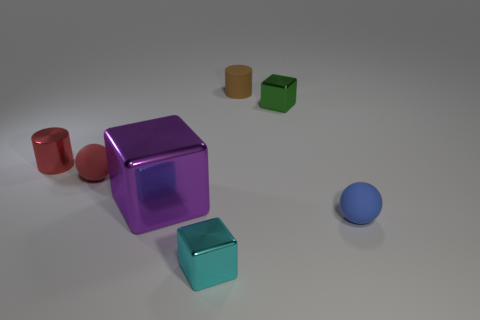Is the shape of the large shiny thing the same as the green object?
Keep it short and to the point. Yes. There is a small matte ball that is to the left of the brown rubber thing; is there a rubber ball that is in front of it?
Provide a short and direct response. Yes. Are there the same number of big purple blocks that are in front of the tiny blue matte object and tiny cyan matte balls?
Offer a terse response. Yes. What number of other things are the same size as the brown object?
Make the answer very short. 5. Does the small blue thing that is in front of the tiny rubber cylinder have the same material as the tiny red object on the left side of the red matte object?
Make the answer very short. No. There is a purple shiny thing in front of the tiny matte sphere to the left of the tiny green metallic object; how big is it?
Give a very brief answer. Large. Are there any matte spheres of the same color as the shiny cylinder?
Provide a succinct answer. Yes. There is a cylinder on the left side of the brown thing; is it the same color as the small cube that is in front of the tiny blue matte object?
Ensure brevity in your answer.  No. The brown rubber object has what shape?
Your response must be concise. Cylinder. There is a purple shiny cube; what number of spheres are right of it?
Keep it short and to the point. 1. 